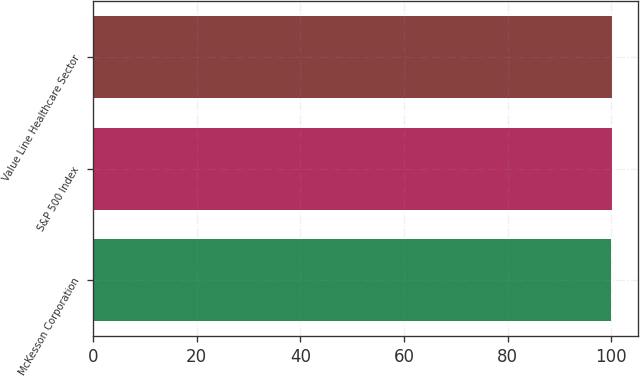<chart> <loc_0><loc_0><loc_500><loc_500><bar_chart><fcel>McKesson Corporation<fcel>S&P 500 Index<fcel>Value Line Healthcare Sector<nl><fcel>100<fcel>100.1<fcel>100.2<nl></chart> 